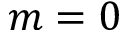Convert formula to latex. <formula><loc_0><loc_0><loc_500><loc_500>m = 0</formula> 